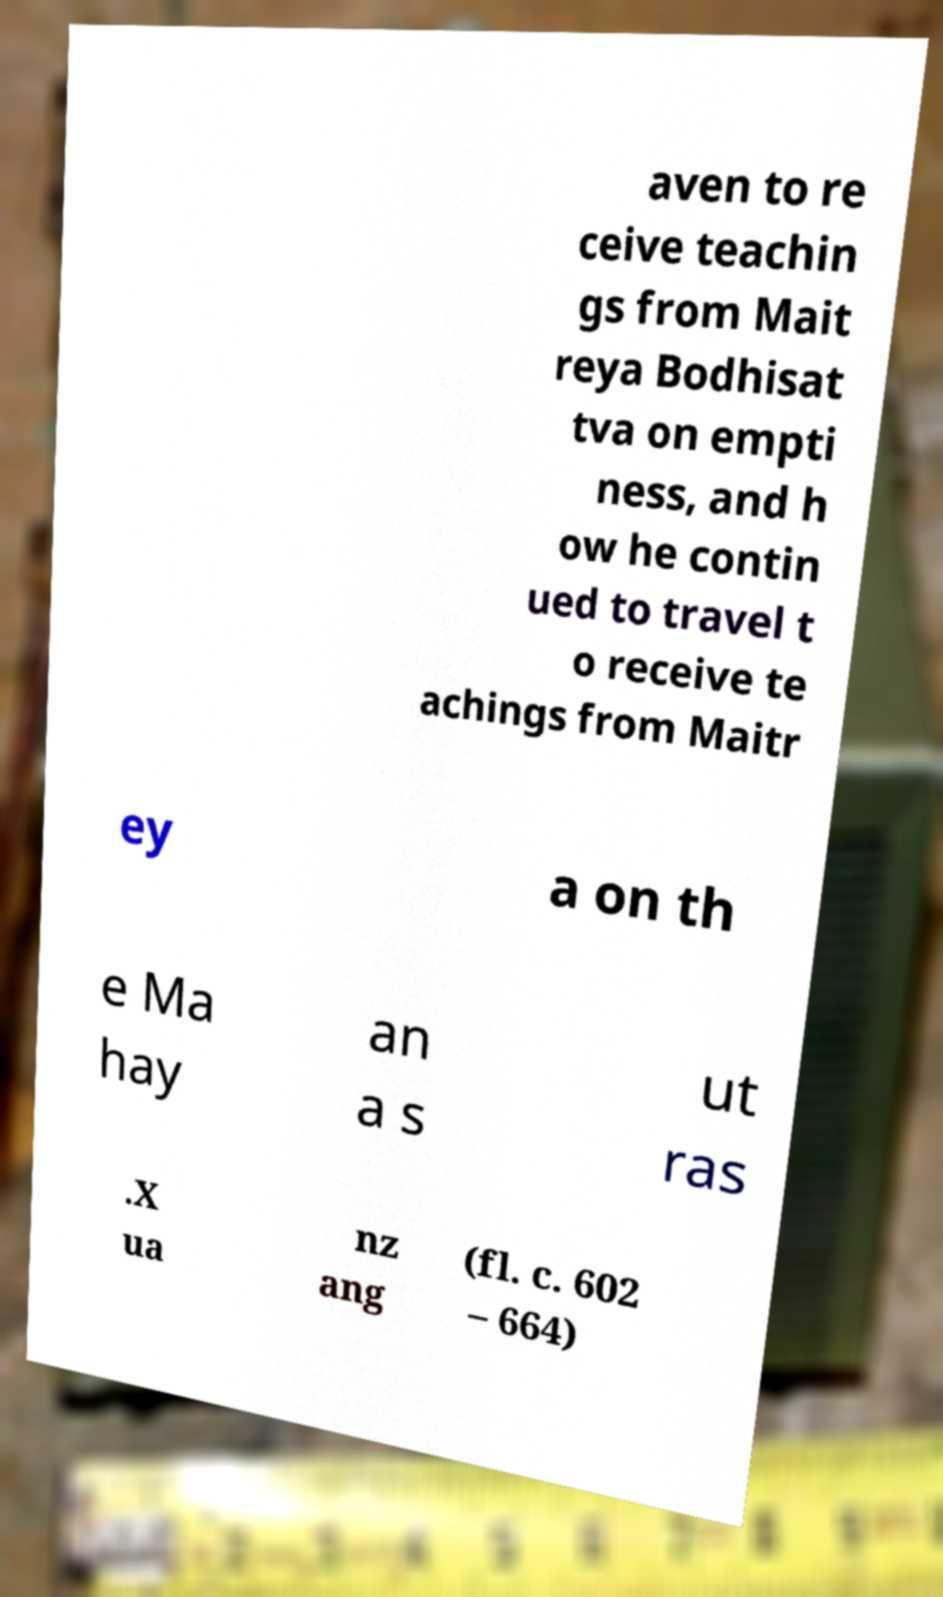Can you read and provide the text displayed in the image?This photo seems to have some interesting text. Can you extract and type it out for me? aven to re ceive teachin gs from Mait reya Bodhisat tva on empti ness, and h ow he contin ued to travel t o receive te achings from Maitr ey a on th e Ma hay an a s ut ras .X ua nz ang (fl. c. 602 – 664) 